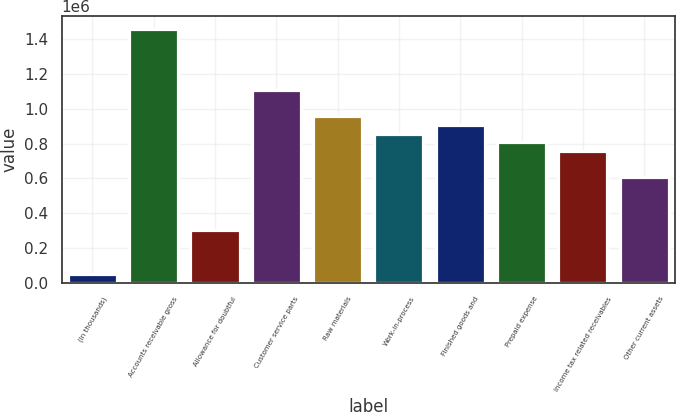Convert chart to OTSL. <chart><loc_0><loc_0><loc_500><loc_500><bar_chart><fcel>(In thousands)<fcel>Accounts receivable gross<fcel>Allowance for doubtful<fcel>Customer service parts<fcel>Raw materials<fcel>Work-in-process<fcel>Finished goods and<fcel>Prepaid expense<fcel>Income tax related receivables<fcel>Other current assets<nl><fcel>51648.1<fcel>1.46128e+06<fcel>303369<fcel>1.10887e+06<fcel>957842<fcel>857154<fcel>907498<fcel>806810<fcel>756466<fcel>605433<nl></chart> 